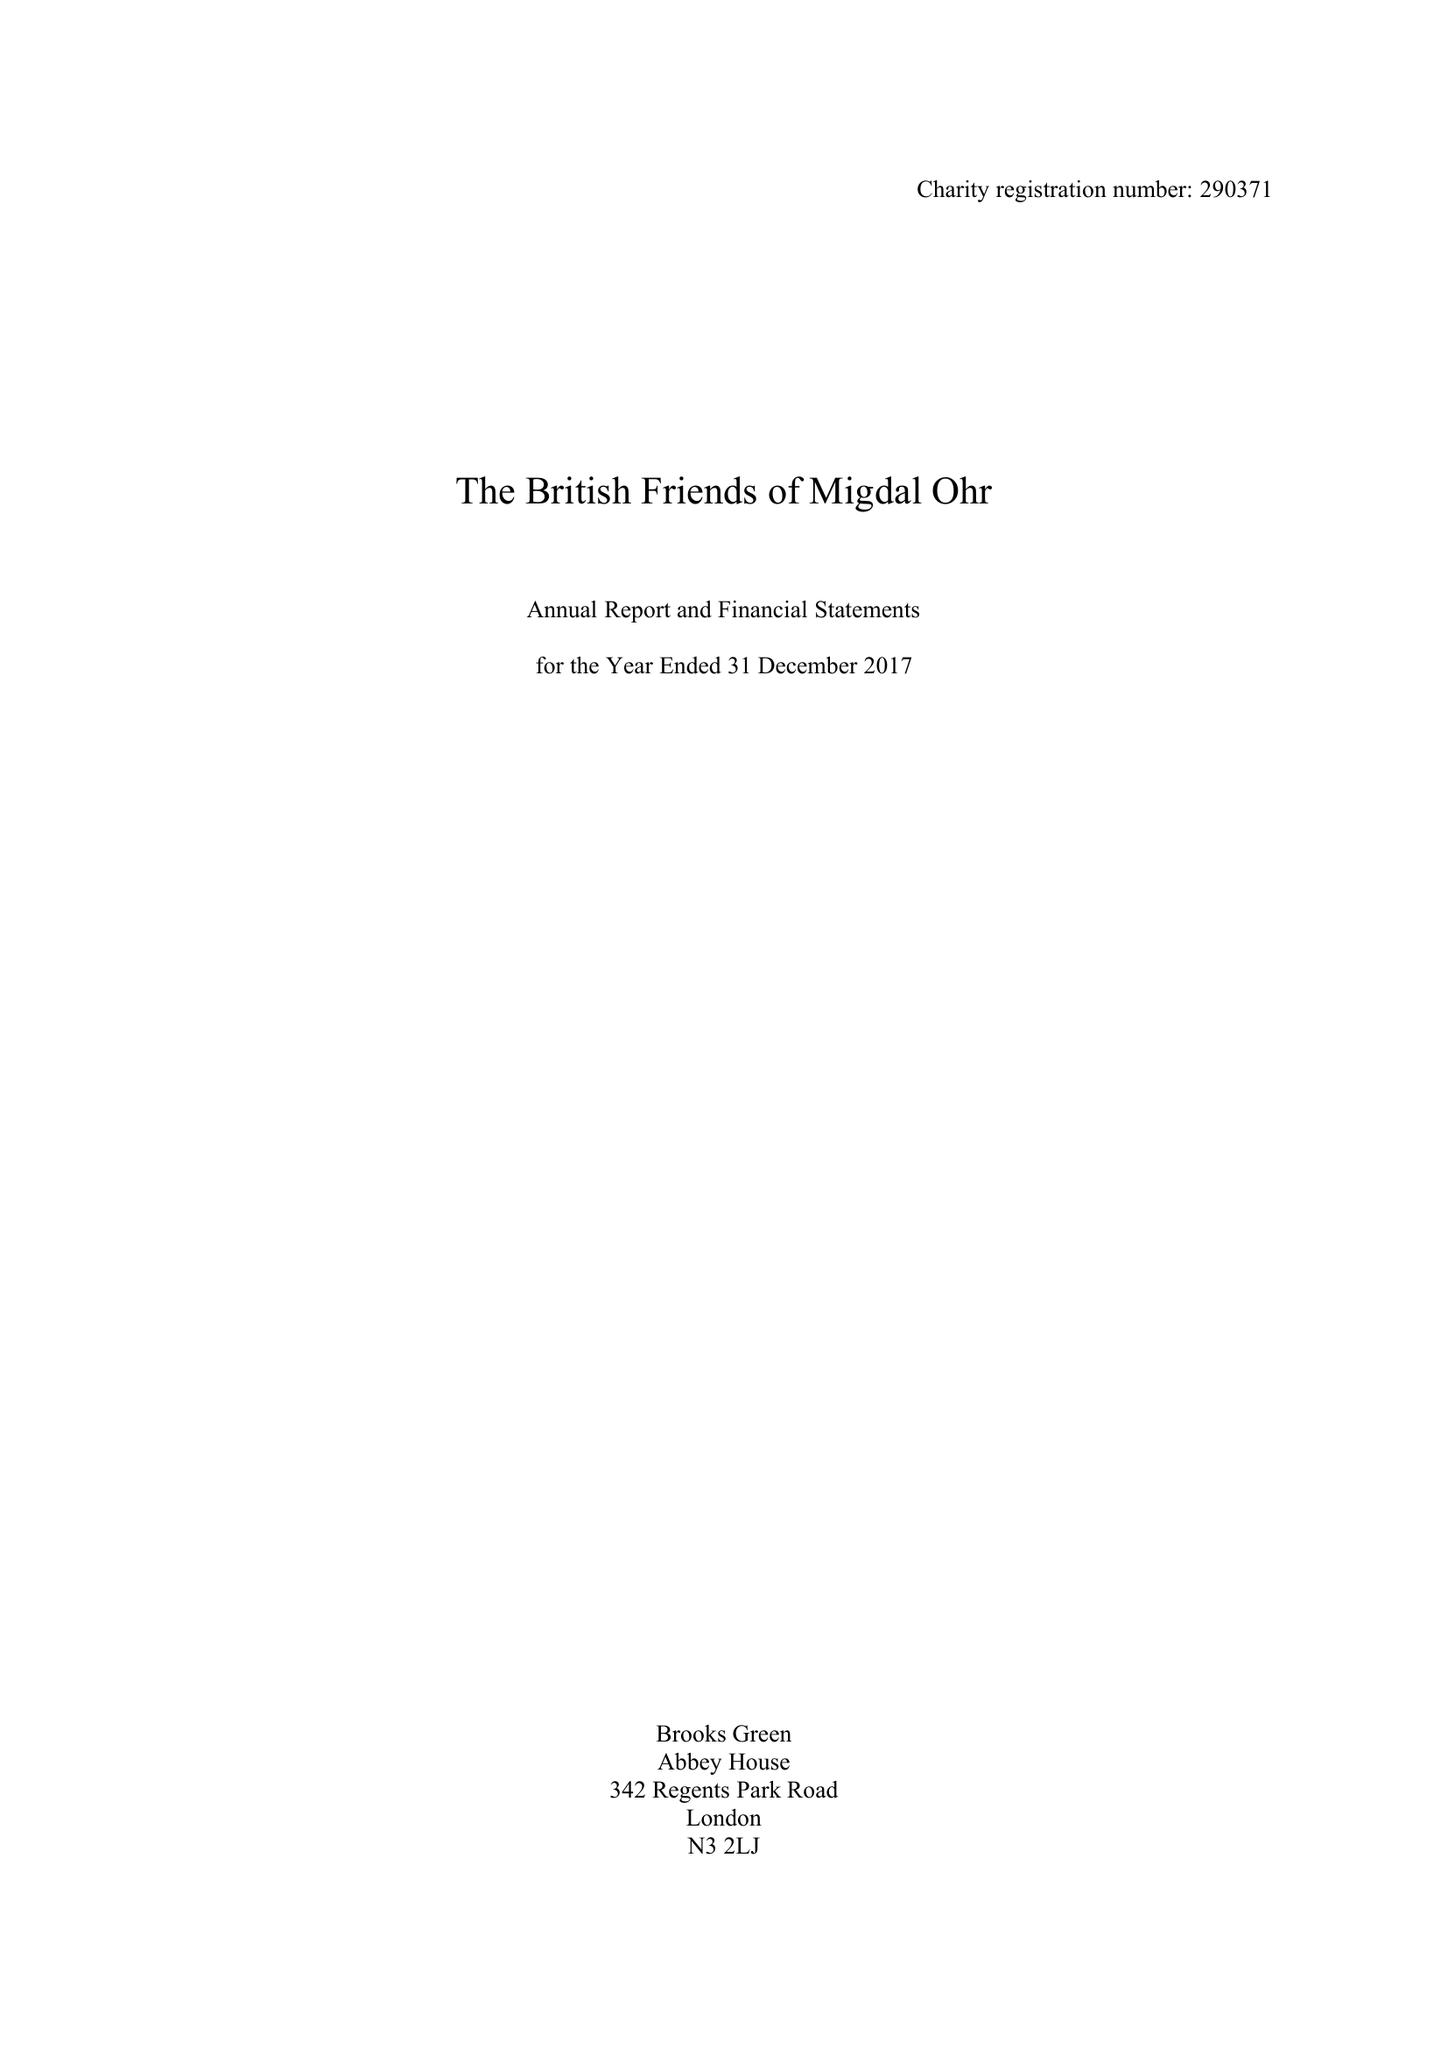What is the value for the address__street_line?
Answer the question using a single word or phrase. 4 FITZHARDINGE STREET 